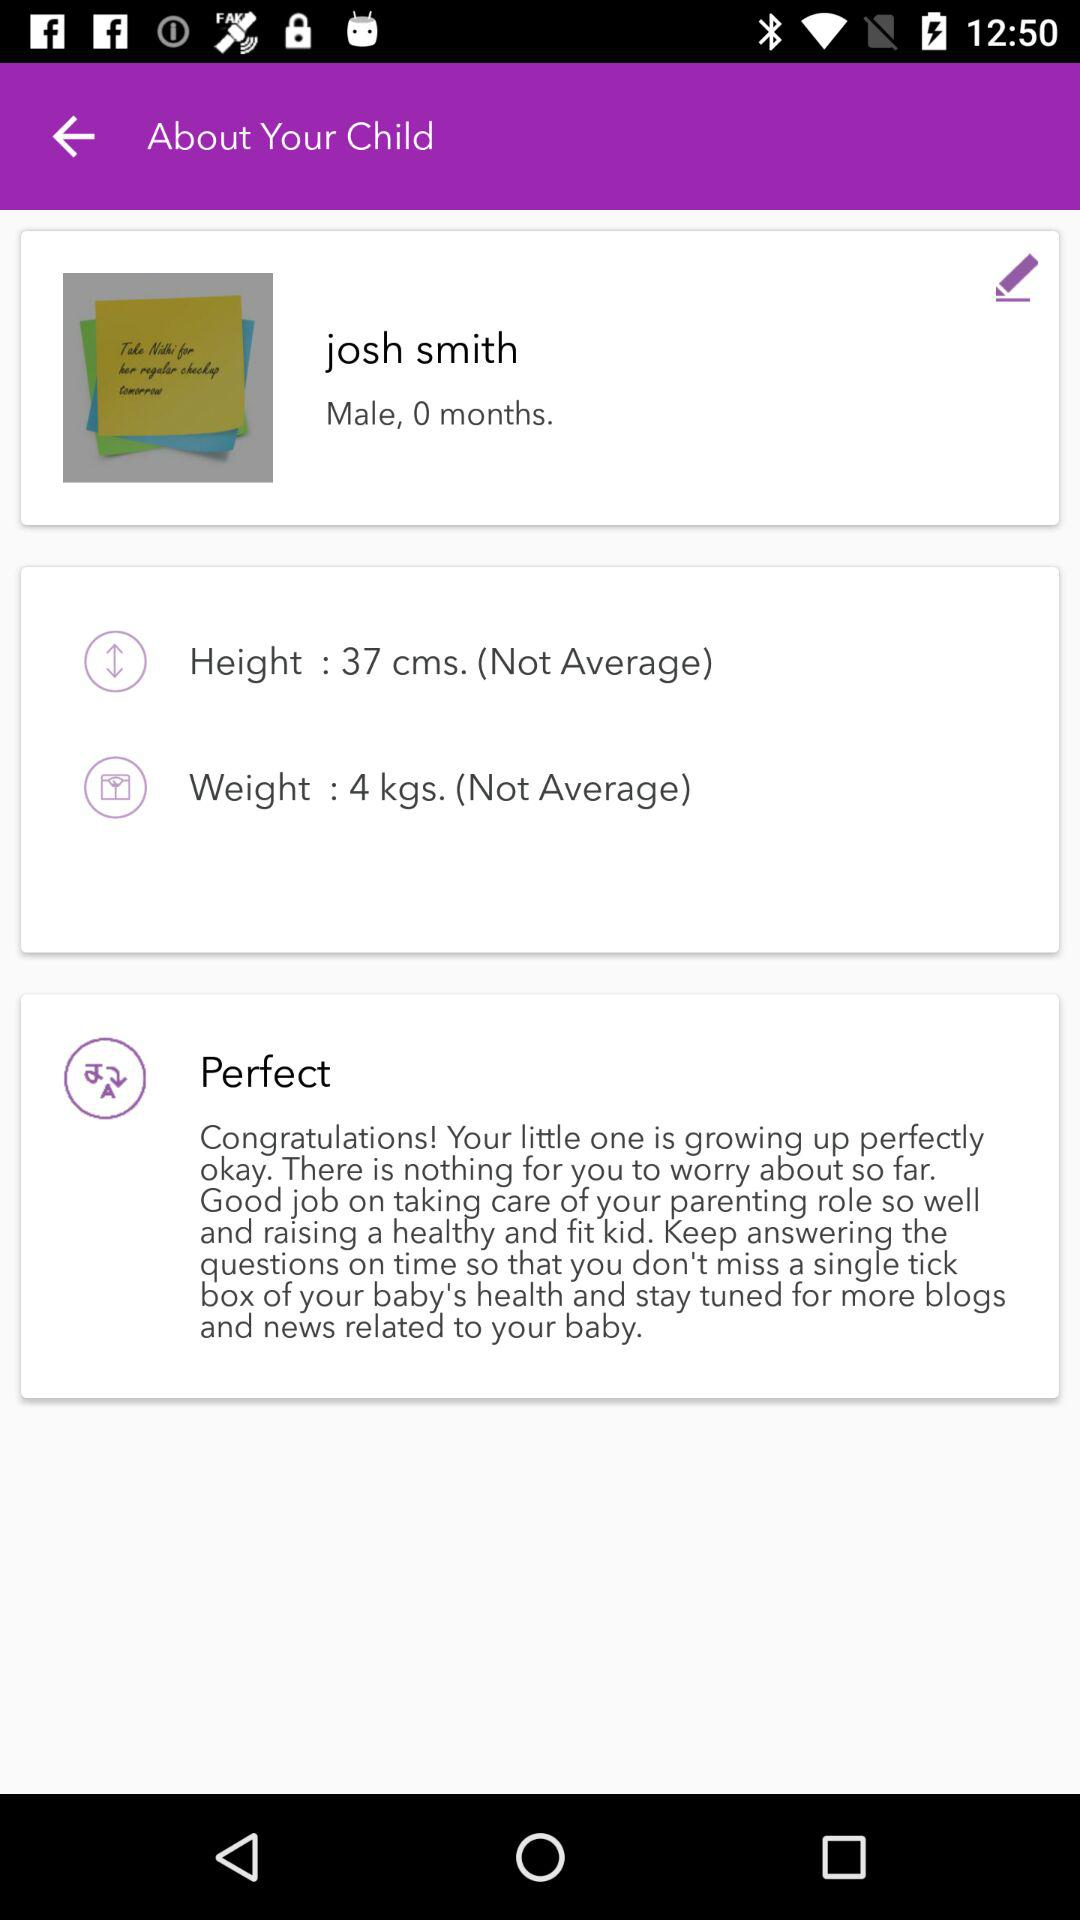What's the height? The height is 37 cm. 